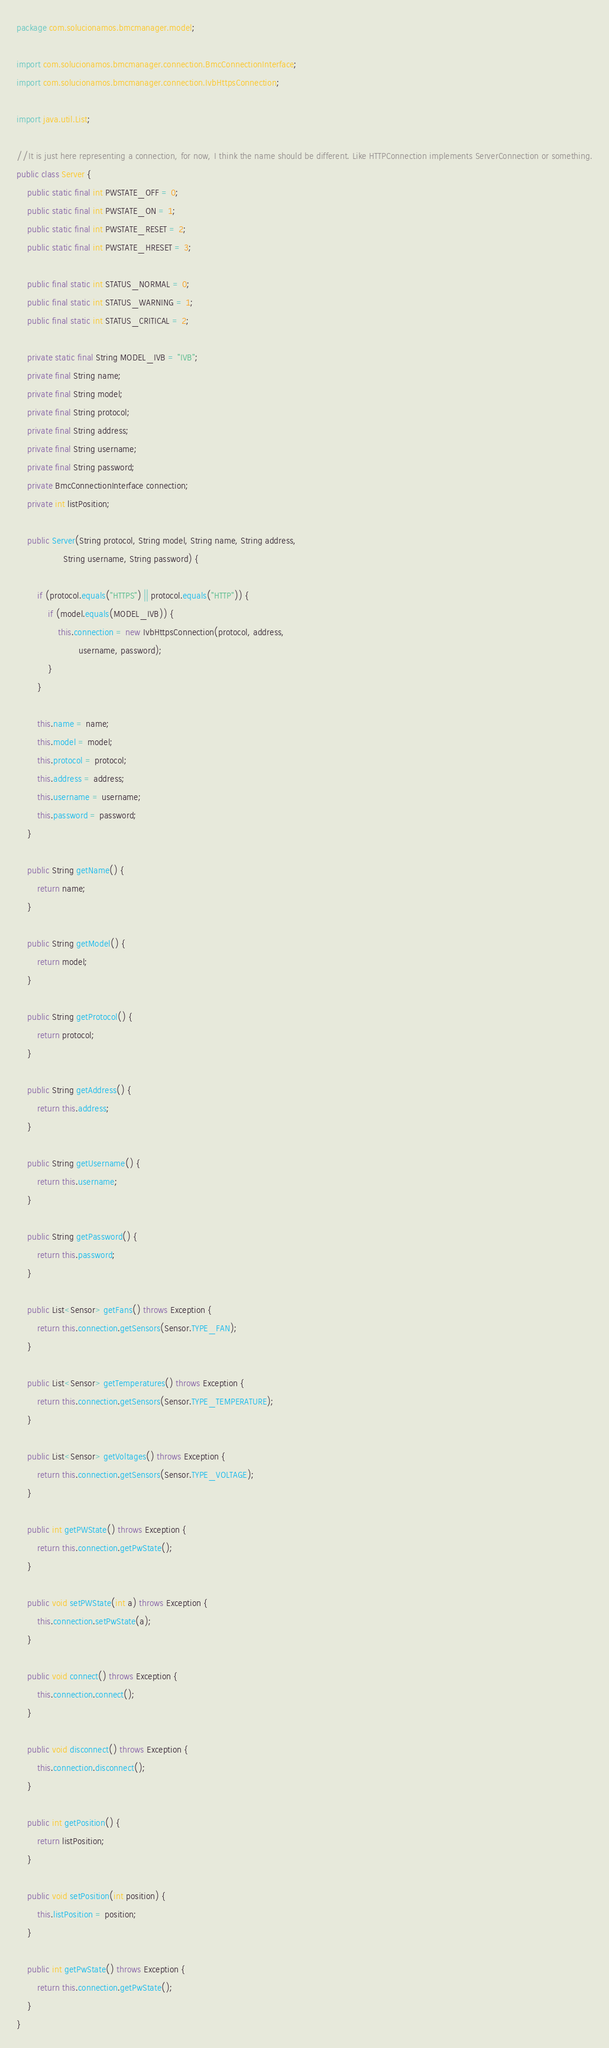Convert code to text. <code><loc_0><loc_0><loc_500><loc_500><_Java_>package com.solucionamos.bmcmanager.model;

import com.solucionamos.bmcmanager.connection.BmcConnectionInterface;
import com.solucionamos.bmcmanager.connection.IvbHttpsConnection;

import java.util.List;

//It is just here representing a connection, for now, I think the name should be different. Like HTTPConnection implements ServerConnection or something.
public class Server {
    public static final int PWSTATE_OFF = 0;
    public static final int PWSTATE_ON = 1;
    public static final int PWSTATE_RESET = 2;
    public static final int PWSTATE_HRESET = 3;

    public final static int STATUS_NORMAL = 0;
    public final static int STATUS_WARNING = 1;
    public final static int STATUS_CRITICAL = 2;

    private static final String MODEL_IVB = "IVB";
    private final String name;
    private final String model;
    private final String protocol;
    private final String address;
    private final String username;
    private final String password;
    private BmcConnectionInterface connection;
    private int listPosition;

    public Server(String protocol, String model, String name, String address,
                  String username, String password) {

        if (protocol.equals("HTTPS") || protocol.equals("HTTP")) {
            if (model.equals(MODEL_IVB)) {
                this.connection = new IvbHttpsConnection(protocol, address,
                        username, password);
            }
        }

        this.name = name;
        this.model = model;
        this.protocol = protocol;
        this.address = address;
        this.username = username;
        this.password = password;
    }

    public String getName() {
        return name;
    }

    public String getModel() {
        return model;
    }

    public String getProtocol() {
        return protocol;
    }

    public String getAddress() {
        return this.address;
    }

    public String getUsername() {
        return this.username;
    }

    public String getPassword() {
        return this.password;
    }

    public List<Sensor> getFans() throws Exception {
        return this.connection.getSensors(Sensor.TYPE_FAN);
    }

    public List<Sensor> getTemperatures() throws Exception {
        return this.connection.getSensors(Sensor.TYPE_TEMPERATURE);
    }

    public List<Sensor> getVoltages() throws Exception {
        return this.connection.getSensors(Sensor.TYPE_VOLTAGE);
    }

    public int getPWState() throws Exception {
        return this.connection.getPwState();
    }

    public void setPWState(int a) throws Exception {
        this.connection.setPwState(a);
    }

    public void connect() throws Exception {
        this.connection.connect();
    }

    public void disconnect() throws Exception {
        this.connection.disconnect();
    }

    public int getPosition() {
        return listPosition;
    }

    public void setPosition(int position) {
        this.listPosition = position;
    }

    public int getPwState() throws Exception {
        return this.connection.getPwState();
    }
}
</code> 